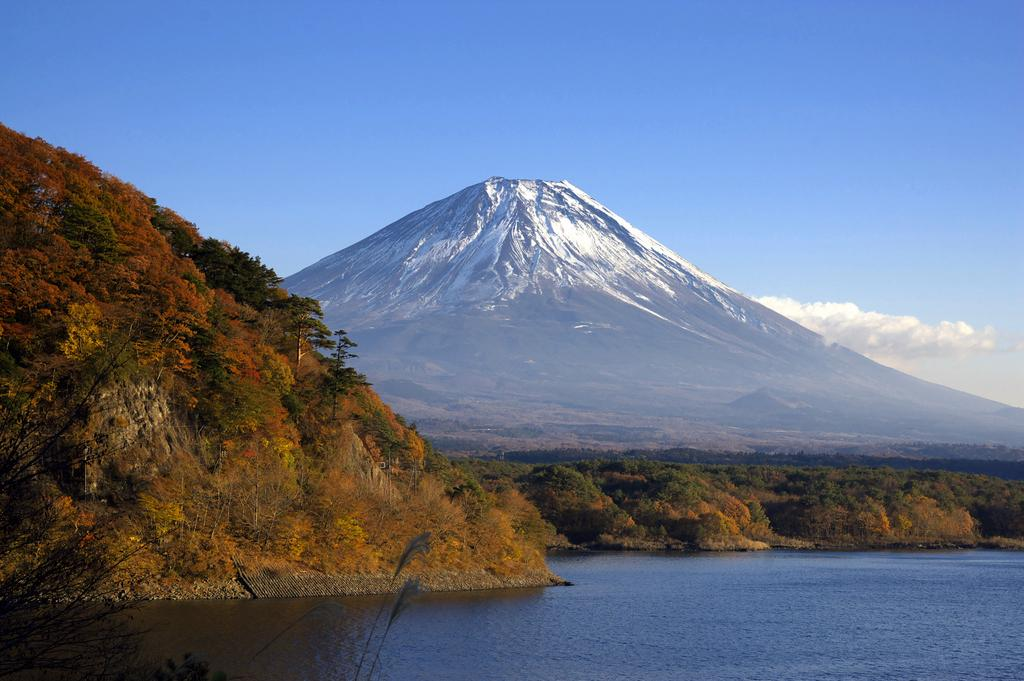What type of natural features can be seen in the image? There are trees and mountains visible in the image. What body of water can be seen in the image? There is water visible in the image. What is visible in the background of the image? The sky is visible in the background of the image. What can be observed in the sky? Clouds are present in the sky. How many oranges are hanging from the trees in the image? There are no oranges visible in the image; it features trees without fruit. What level of attention is required to begin understanding the image? The image is straightforward and does not require a specific level of attention to understand. 